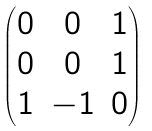<formula> <loc_0><loc_0><loc_500><loc_500>\begin{pmatrix} 0 & 0 & 1 \\ 0 & 0 & 1 \\ 1 & - 1 & 0 \end{pmatrix}</formula> 